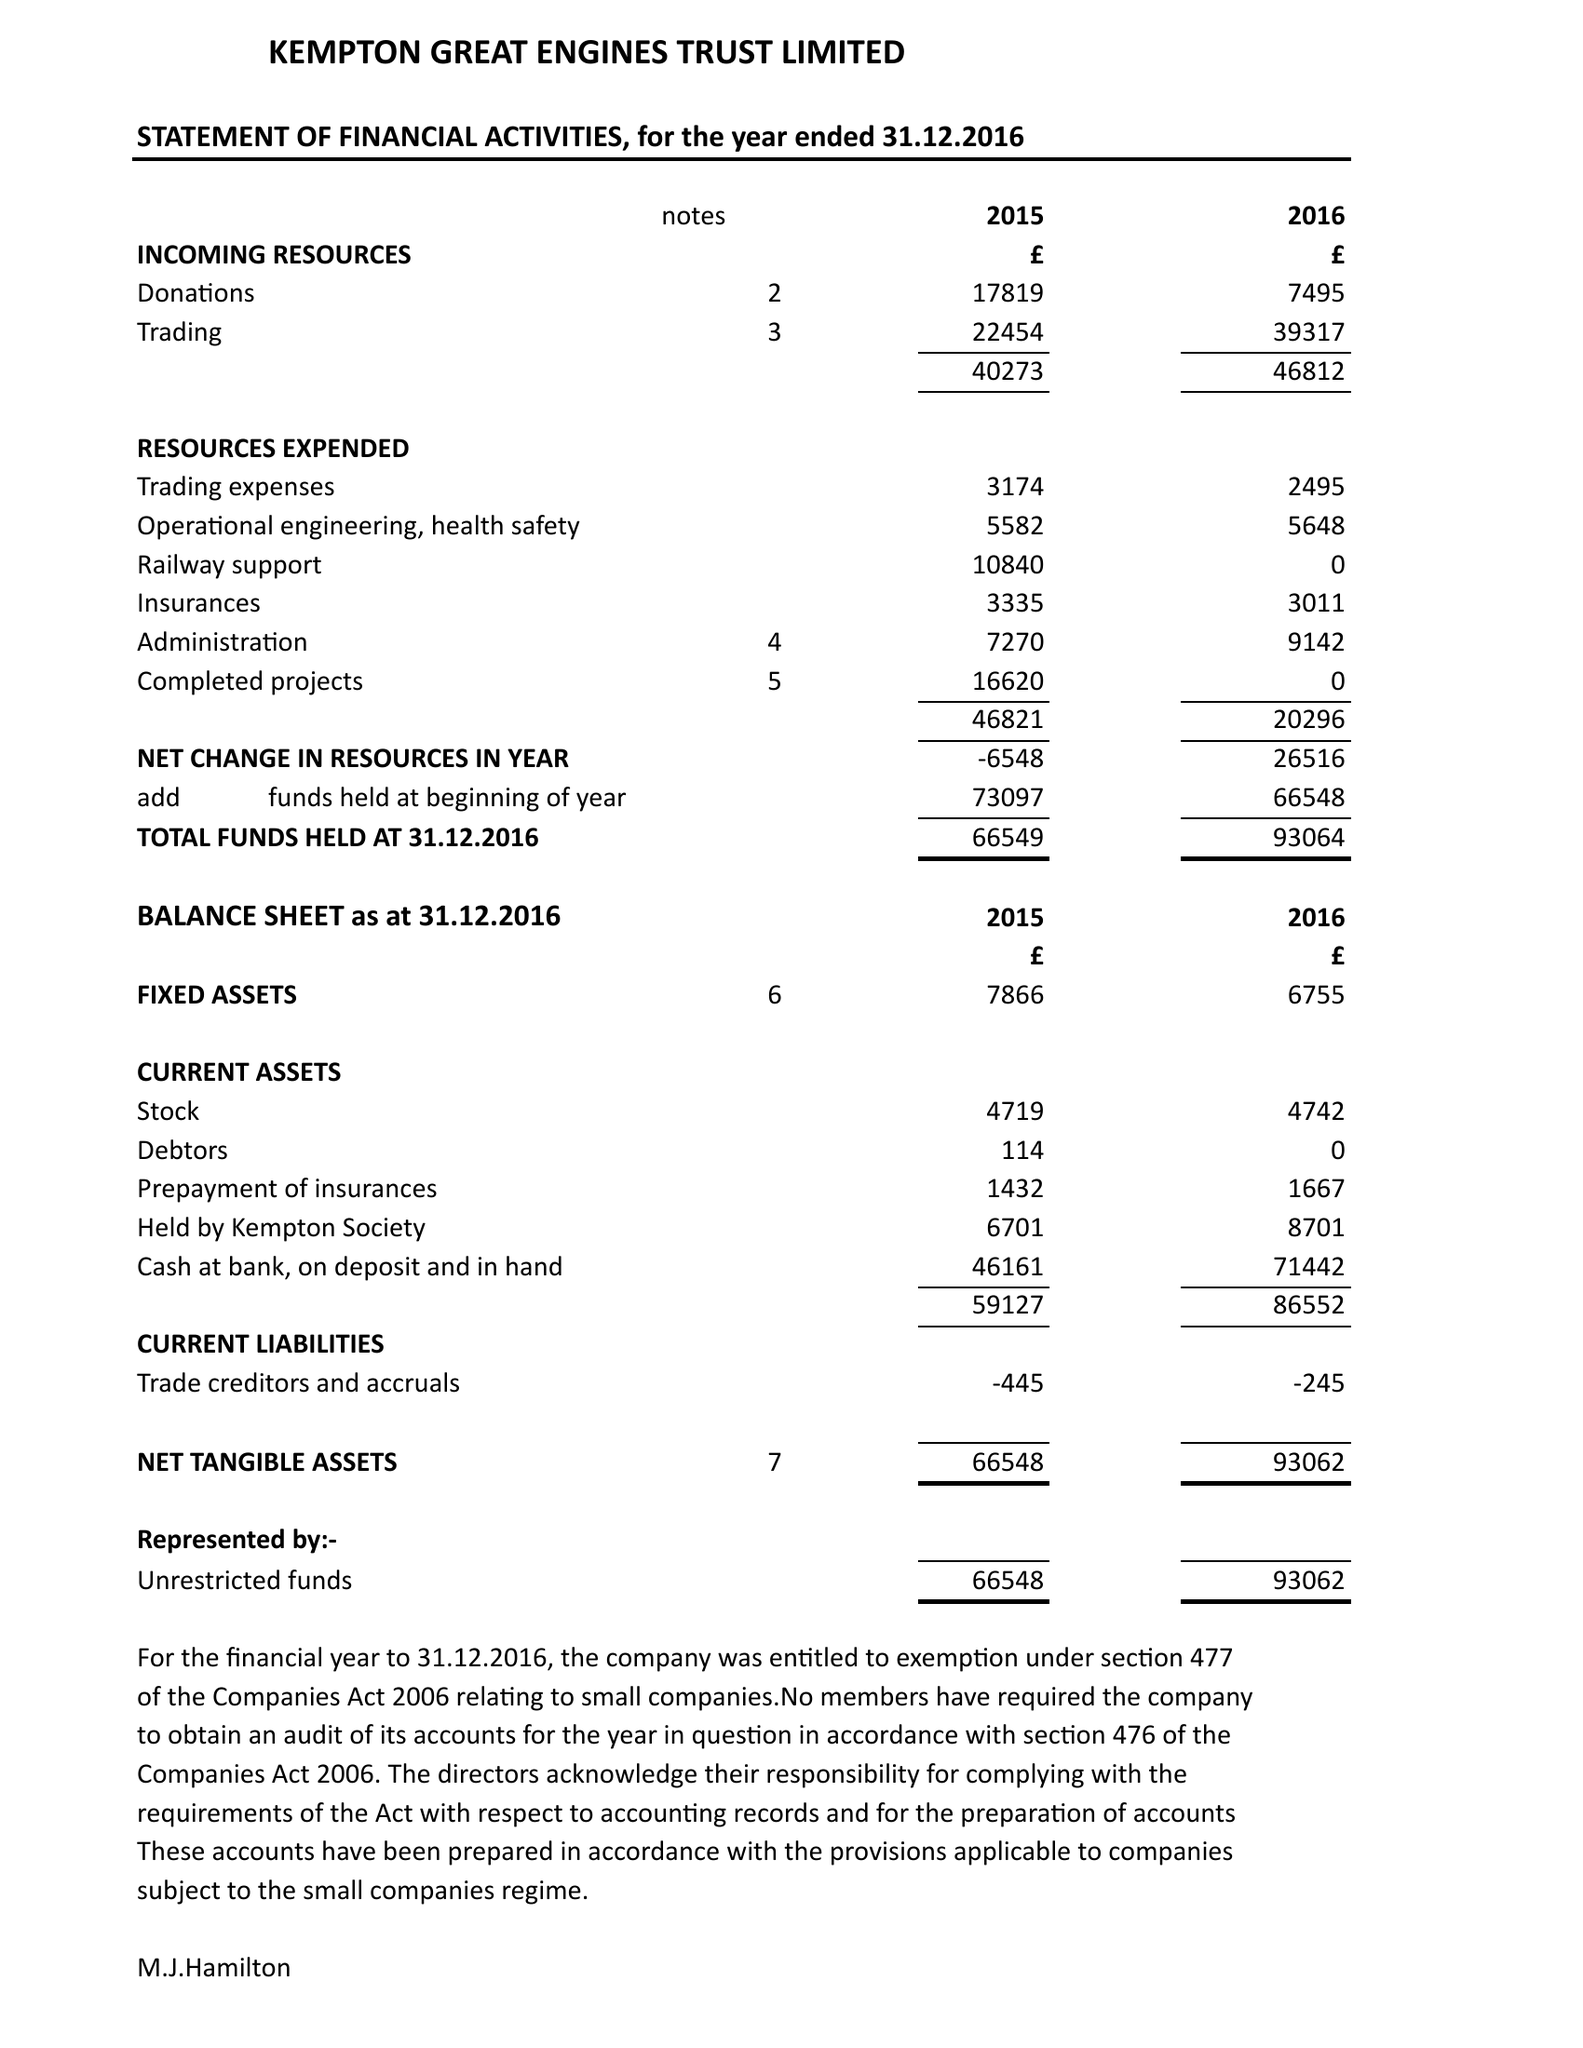What is the value for the charity_number?
Answer the question using a single word or phrase. 1048936 